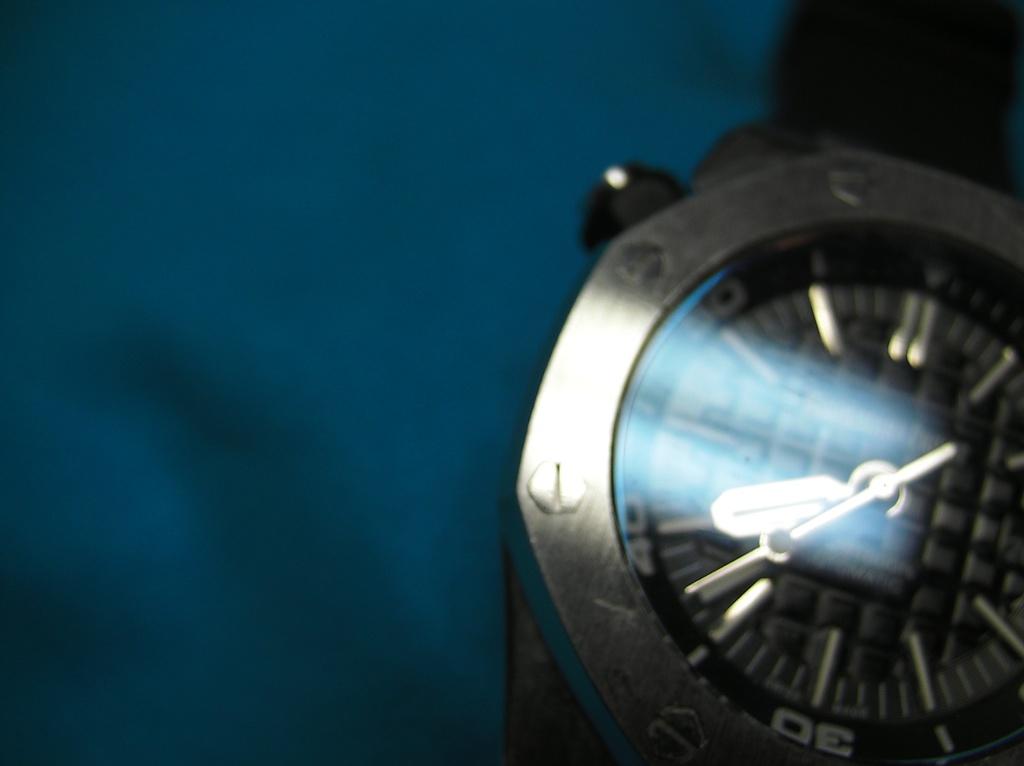What number is shown at the bottom?
Your answer should be very brief. 30. 